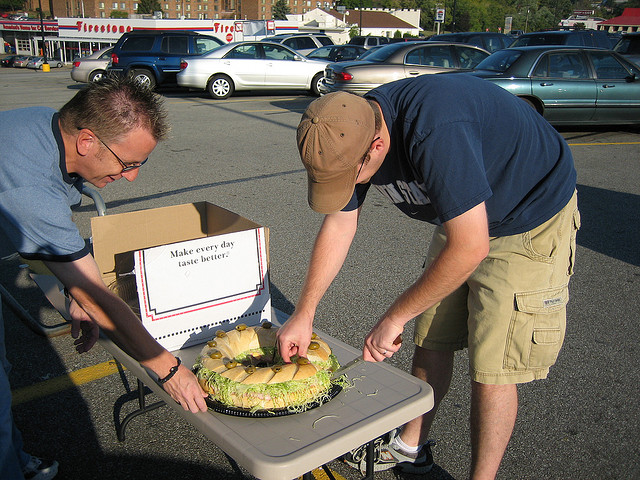Identify the text contained in this image. day Make every taste better 